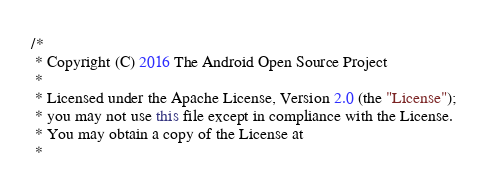<code> <loc_0><loc_0><loc_500><loc_500><_Java_>/*
 * Copyright (C) 2016 The Android Open Source Project
 *
 * Licensed under the Apache License, Version 2.0 (the "License");
 * you may not use this file except in compliance with the License.
 * You may obtain a copy of the License at
 *</code> 